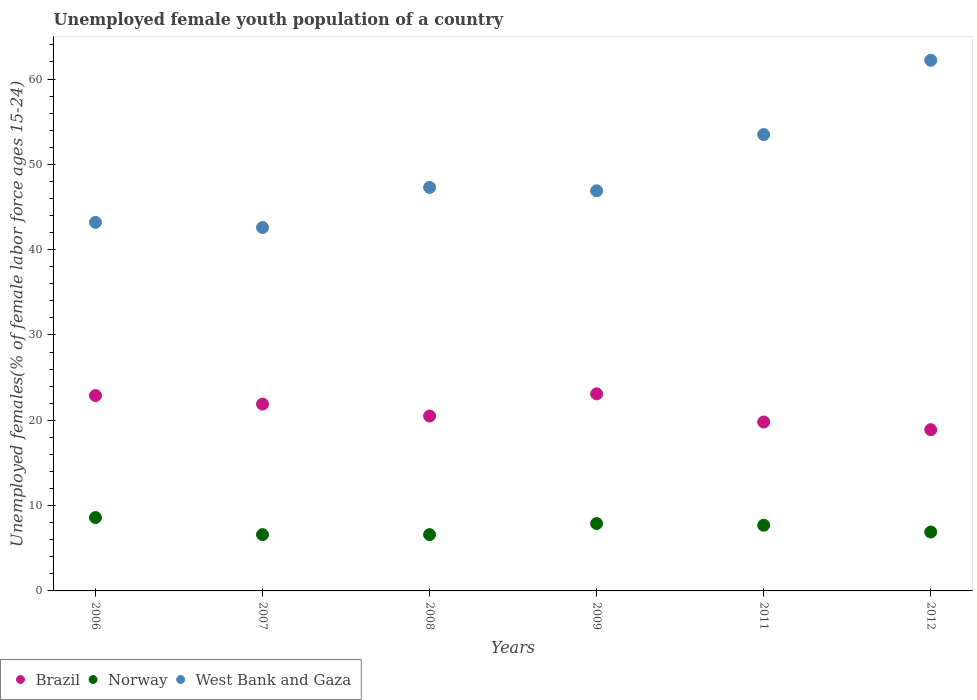Is the number of dotlines equal to the number of legend labels?
Give a very brief answer. Yes. What is the percentage of unemployed female youth population in Norway in 2012?
Ensure brevity in your answer.  6.9. Across all years, what is the maximum percentage of unemployed female youth population in West Bank and Gaza?
Keep it short and to the point. 62.2. Across all years, what is the minimum percentage of unemployed female youth population in West Bank and Gaza?
Keep it short and to the point. 42.6. In which year was the percentage of unemployed female youth population in Norway maximum?
Make the answer very short. 2006. What is the total percentage of unemployed female youth population in Norway in the graph?
Make the answer very short. 44.3. What is the difference between the percentage of unemployed female youth population in Norway in 2007 and that in 2011?
Your answer should be very brief. -1.1. What is the difference between the percentage of unemployed female youth population in Brazil in 2011 and the percentage of unemployed female youth population in West Bank and Gaza in 2007?
Offer a terse response. -22.8. What is the average percentage of unemployed female youth population in West Bank and Gaza per year?
Keep it short and to the point. 49.28. In the year 2012, what is the difference between the percentage of unemployed female youth population in Brazil and percentage of unemployed female youth population in West Bank and Gaza?
Your response must be concise. -43.3. In how many years, is the percentage of unemployed female youth population in Norway greater than 12 %?
Provide a short and direct response. 0. What is the ratio of the percentage of unemployed female youth population in Brazil in 2006 to that in 2011?
Ensure brevity in your answer.  1.16. What is the difference between the highest and the second highest percentage of unemployed female youth population in Norway?
Provide a succinct answer. 0.7. What is the difference between the highest and the lowest percentage of unemployed female youth population in Norway?
Provide a succinct answer. 2. Is the sum of the percentage of unemployed female youth population in Brazil in 2006 and 2008 greater than the maximum percentage of unemployed female youth population in West Bank and Gaza across all years?
Give a very brief answer. No. Is the percentage of unemployed female youth population in Norway strictly greater than the percentage of unemployed female youth population in Brazil over the years?
Offer a very short reply. No. Is the percentage of unemployed female youth population in Brazil strictly less than the percentage of unemployed female youth population in Norway over the years?
Keep it short and to the point. No. How many dotlines are there?
Your response must be concise. 3. How many legend labels are there?
Provide a short and direct response. 3. What is the title of the graph?
Provide a succinct answer. Unemployed female youth population of a country. What is the label or title of the X-axis?
Keep it short and to the point. Years. What is the label or title of the Y-axis?
Give a very brief answer. Unemployed females(% of female labor force ages 15-24). What is the Unemployed females(% of female labor force ages 15-24) in Brazil in 2006?
Offer a terse response. 22.9. What is the Unemployed females(% of female labor force ages 15-24) in Norway in 2006?
Your answer should be very brief. 8.6. What is the Unemployed females(% of female labor force ages 15-24) in West Bank and Gaza in 2006?
Your answer should be compact. 43.2. What is the Unemployed females(% of female labor force ages 15-24) in Brazil in 2007?
Offer a very short reply. 21.9. What is the Unemployed females(% of female labor force ages 15-24) in Norway in 2007?
Make the answer very short. 6.6. What is the Unemployed females(% of female labor force ages 15-24) of West Bank and Gaza in 2007?
Provide a short and direct response. 42.6. What is the Unemployed females(% of female labor force ages 15-24) in Brazil in 2008?
Offer a very short reply. 20.5. What is the Unemployed females(% of female labor force ages 15-24) of Norway in 2008?
Provide a succinct answer. 6.6. What is the Unemployed females(% of female labor force ages 15-24) in West Bank and Gaza in 2008?
Offer a terse response. 47.3. What is the Unemployed females(% of female labor force ages 15-24) of Brazil in 2009?
Make the answer very short. 23.1. What is the Unemployed females(% of female labor force ages 15-24) of Norway in 2009?
Ensure brevity in your answer.  7.9. What is the Unemployed females(% of female labor force ages 15-24) in West Bank and Gaza in 2009?
Give a very brief answer. 46.9. What is the Unemployed females(% of female labor force ages 15-24) of Brazil in 2011?
Give a very brief answer. 19.8. What is the Unemployed females(% of female labor force ages 15-24) of Norway in 2011?
Give a very brief answer. 7.7. What is the Unemployed females(% of female labor force ages 15-24) of West Bank and Gaza in 2011?
Provide a succinct answer. 53.5. What is the Unemployed females(% of female labor force ages 15-24) in Brazil in 2012?
Make the answer very short. 18.9. What is the Unemployed females(% of female labor force ages 15-24) of Norway in 2012?
Your response must be concise. 6.9. What is the Unemployed females(% of female labor force ages 15-24) in West Bank and Gaza in 2012?
Your response must be concise. 62.2. Across all years, what is the maximum Unemployed females(% of female labor force ages 15-24) of Brazil?
Your answer should be very brief. 23.1. Across all years, what is the maximum Unemployed females(% of female labor force ages 15-24) in Norway?
Your answer should be compact. 8.6. Across all years, what is the maximum Unemployed females(% of female labor force ages 15-24) in West Bank and Gaza?
Make the answer very short. 62.2. Across all years, what is the minimum Unemployed females(% of female labor force ages 15-24) in Brazil?
Provide a short and direct response. 18.9. Across all years, what is the minimum Unemployed females(% of female labor force ages 15-24) in Norway?
Your response must be concise. 6.6. Across all years, what is the minimum Unemployed females(% of female labor force ages 15-24) of West Bank and Gaza?
Give a very brief answer. 42.6. What is the total Unemployed females(% of female labor force ages 15-24) in Brazil in the graph?
Offer a very short reply. 127.1. What is the total Unemployed females(% of female labor force ages 15-24) in Norway in the graph?
Keep it short and to the point. 44.3. What is the total Unemployed females(% of female labor force ages 15-24) in West Bank and Gaza in the graph?
Your response must be concise. 295.7. What is the difference between the Unemployed females(% of female labor force ages 15-24) in Norway in 2006 and that in 2007?
Your answer should be very brief. 2. What is the difference between the Unemployed females(% of female labor force ages 15-24) of West Bank and Gaza in 2006 and that in 2007?
Keep it short and to the point. 0.6. What is the difference between the Unemployed females(% of female labor force ages 15-24) in Brazil in 2006 and that in 2008?
Make the answer very short. 2.4. What is the difference between the Unemployed females(% of female labor force ages 15-24) of West Bank and Gaza in 2006 and that in 2008?
Your answer should be compact. -4.1. What is the difference between the Unemployed females(% of female labor force ages 15-24) of Brazil in 2006 and that in 2009?
Offer a very short reply. -0.2. What is the difference between the Unemployed females(% of female labor force ages 15-24) of West Bank and Gaza in 2006 and that in 2009?
Your answer should be very brief. -3.7. What is the difference between the Unemployed females(% of female labor force ages 15-24) of West Bank and Gaza in 2006 and that in 2011?
Your answer should be compact. -10.3. What is the difference between the Unemployed females(% of female labor force ages 15-24) in West Bank and Gaza in 2007 and that in 2008?
Provide a succinct answer. -4.7. What is the difference between the Unemployed females(% of female labor force ages 15-24) in Norway in 2007 and that in 2009?
Your response must be concise. -1.3. What is the difference between the Unemployed females(% of female labor force ages 15-24) of West Bank and Gaza in 2007 and that in 2009?
Provide a short and direct response. -4.3. What is the difference between the Unemployed females(% of female labor force ages 15-24) in Norway in 2007 and that in 2011?
Make the answer very short. -1.1. What is the difference between the Unemployed females(% of female labor force ages 15-24) of Brazil in 2007 and that in 2012?
Your answer should be compact. 3. What is the difference between the Unemployed females(% of female labor force ages 15-24) in West Bank and Gaza in 2007 and that in 2012?
Give a very brief answer. -19.6. What is the difference between the Unemployed females(% of female labor force ages 15-24) of West Bank and Gaza in 2008 and that in 2009?
Your answer should be very brief. 0.4. What is the difference between the Unemployed females(% of female labor force ages 15-24) of Norway in 2008 and that in 2012?
Ensure brevity in your answer.  -0.3. What is the difference between the Unemployed females(% of female labor force ages 15-24) in West Bank and Gaza in 2008 and that in 2012?
Offer a terse response. -14.9. What is the difference between the Unemployed females(% of female labor force ages 15-24) in Brazil in 2009 and that in 2011?
Offer a terse response. 3.3. What is the difference between the Unemployed females(% of female labor force ages 15-24) in West Bank and Gaza in 2009 and that in 2012?
Offer a very short reply. -15.3. What is the difference between the Unemployed females(% of female labor force ages 15-24) in Brazil in 2011 and that in 2012?
Give a very brief answer. 0.9. What is the difference between the Unemployed females(% of female labor force ages 15-24) of Brazil in 2006 and the Unemployed females(% of female labor force ages 15-24) of Norway in 2007?
Your answer should be very brief. 16.3. What is the difference between the Unemployed females(% of female labor force ages 15-24) of Brazil in 2006 and the Unemployed females(% of female labor force ages 15-24) of West Bank and Gaza in 2007?
Provide a short and direct response. -19.7. What is the difference between the Unemployed females(% of female labor force ages 15-24) in Norway in 2006 and the Unemployed females(% of female labor force ages 15-24) in West Bank and Gaza in 2007?
Provide a succinct answer. -34. What is the difference between the Unemployed females(% of female labor force ages 15-24) of Brazil in 2006 and the Unemployed females(% of female labor force ages 15-24) of Norway in 2008?
Offer a terse response. 16.3. What is the difference between the Unemployed females(% of female labor force ages 15-24) in Brazil in 2006 and the Unemployed females(% of female labor force ages 15-24) in West Bank and Gaza in 2008?
Offer a very short reply. -24.4. What is the difference between the Unemployed females(% of female labor force ages 15-24) in Norway in 2006 and the Unemployed females(% of female labor force ages 15-24) in West Bank and Gaza in 2008?
Your answer should be very brief. -38.7. What is the difference between the Unemployed females(% of female labor force ages 15-24) of Norway in 2006 and the Unemployed females(% of female labor force ages 15-24) of West Bank and Gaza in 2009?
Provide a succinct answer. -38.3. What is the difference between the Unemployed females(% of female labor force ages 15-24) of Brazil in 2006 and the Unemployed females(% of female labor force ages 15-24) of West Bank and Gaza in 2011?
Offer a terse response. -30.6. What is the difference between the Unemployed females(% of female labor force ages 15-24) in Norway in 2006 and the Unemployed females(% of female labor force ages 15-24) in West Bank and Gaza in 2011?
Give a very brief answer. -44.9. What is the difference between the Unemployed females(% of female labor force ages 15-24) of Brazil in 2006 and the Unemployed females(% of female labor force ages 15-24) of West Bank and Gaza in 2012?
Offer a terse response. -39.3. What is the difference between the Unemployed females(% of female labor force ages 15-24) of Norway in 2006 and the Unemployed females(% of female labor force ages 15-24) of West Bank and Gaza in 2012?
Provide a succinct answer. -53.6. What is the difference between the Unemployed females(% of female labor force ages 15-24) of Brazil in 2007 and the Unemployed females(% of female labor force ages 15-24) of Norway in 2008?
Your response must be concise. 15.3. What is the difference between the Unemployed females(% of female labor force ages 15-24) of Brazil in 2007 and the Unemployed females(% of female labor force ages 15-24) of West Bank and Gaza in 2008?
Make the answer very short. -25.4. What is the difference between the Unemployed females(% of female labor force ages 15-24) in Norway in 2007 and the Unemployed females(% of female labor force ages 15-24) in West Bank and Gaza in 2008?
Keep it short and to the point. -40.7. What is the difference between the Unemployed females(% of female labor force ages 15-24) in Norway in 2007 and the Unemployed females(% of female labor force ages 15-24) in West Bank and Gaza in 2009?
Keep it short and to the point. -40.3. What is the difference between the Unemployed females(% of female labor force ages 15-24) of Brazil in 2007 and the Unemployed females(% of female labor force ages 15-24) of Norway in 2011?
Offer a very short reply. 14.2. What is the difference between the Unemployed females(% of female labor force ages 15-24) of Brazil in 2007 and the Unemployed females(% of female labor force ages 15-24) of West Bank and Gaza in 2011?
Offer a very short reply. -31.6. What is the difference between the Unemployed females(% of female labor force ages 15-24) of Norway in 2007 and the Unemployed females(% of female labor force ages 15-24) of West Bank and Gaza in 2011?
Offer a very short reply. -46.9. What is the difference between the Unemployed females(% of female labor force ages 15-24) of Brazil in 2007 and the Unemployed females(% of female labor force ages 15-24) of Norway in 2012?
Offer a terse response. 15. What is the difference between the Unemployed females(% of female labor force ages 15-24) in Brazil in 2007 and the Unemployed females(% of female labor force ages 15-24) in West Bank and Gaza in 2012?
Provide a succinct answer. -40.3. What is the difference between the Unemployed females(% of female labor force ages 15-24) of Norway in 2007 and the Unemployed females(% of female labor force ages 15-24) of West Bank and Gaza in 2012?
Ensure brevity in your answer.  -55.6. What is the difference between the Unemployed females(% of female labor force ages 15-24) in Brazil in 2008 and the Unemployed females(% of female labor force ages 15-24) in West Bank and Gaza in 2009?
Ensure brevity in your answer.  -26.4. What is the difference between the Unemployed females(% of female labor force ages 15-24) in Norway in 2008 and the Unemployed females(% of female labor force ages 15-24) in West Bank and Gaza in 2009?
Provide a short and direct response. -40.3. What is the difference between the Unemployed females(% of female labor force ages 15-24) in Brazil in 2008 and the Unemployed females(% of female labor force ages 15-24) in Norway in 2011?
Make the answer very short. 12.8. What is the difference between the Unemployed females(% of female labor force ages 15-24) of Brazil in 2008 and the Unemployed females(% of female labor force ages 15-24) of West Bank and Gaza in 2011?
Ensure brevity in your answer.  -33. What is the difference between the Unemployed females(% of female labor force ages 15-24) of Norway in 2008 and the Unemployed females(% of female labor force ages 15-24) of West Bank and Gaza in 2011?
Provide a succinct answer. -46.9. What is the difference between the Unemployed females(% of female labor force ages 15-24) in Brazil in 2008 and the Unemployed females(% of female labor force ages 15-24) in West Bank and Gaza in 2012?
Your answer should be very brief. -41.7. What is the difference between the Unemployed females(% of female labor force ages 15-24) of Norway in 2008 and the Unemployed females(% of female labor force ages 15-24) of West Bank and Gaza in 2012?
Your answer should be very brief. -55.6. What is the difference between the Unemployed females(% of female labor force ages 15-24) in Brazil in 2009 and the Unemployed females(% of female labor force ages 15-24) in West Bank and Gaza in 2011?
Your answer should be very brief. -30.4. What is the difference between the Unemployed females(% of female labor force ages 15-24) of Norway in 2009 and the Unemployed females(% of female labor force ages 15-24) of West Bank and Gaza in 2011?
Your answer should be very brief. -45.6. What is the difference between the Unemployed females(% of female labor force ages 15-24) of Brazil in 2009 and the Unemployed females(% of female labor force ages 15-24) of Norway in 2012?
Provide a short and direct response. 16.2. What is the difference between the Unemployed females(% of female labor force ages 15-24) in Brazil in 2009 and the Unemployed females(% of female labor force ages 15-24) in West Bank and Gaza in 2012?
Keep it short and to the point. -39.1. What is the difference between the Unemployed females(% of female labor force ages 15-24) of Norway in 2009 and the Unemployed females(% of female labor force ages 15-24) of West Bank and Gaza in 2012?
Provide a succinct answer. -54.3. What is the difference between the Unemployed females(% of female labor force ages 15-24) in Brazil in 2011 and the Unemployed females(% of female labor force ages 15-24) in West Bank and Gaza in 2012?
Give a very brief answer. -42.4. What is the difference between the Unemployed females(% of female labor force ages 15-24) of Norway in 2011 and the Unemployed females(% of female labor force ages 15-24) of West Bank and Gaza in 2012?
Offer a very short reply. -54.5. What is the average Unemployed females(% of female labor force ages 15-24) of Brazil per year?
Keep it short and to the point. 21.18. What is the average Unemployed females(% of female labor force ages 15-24) in Norway per year?
Your answer should be very brief. 7.38. What is the average Unemployed females(% of female labor force ages 15-24) of West Bank and Gaza per year?
Your answer should be compact. 49.28. In the year 2006, what is the difference between the Unemployed females(% of female labor force ages 15-24) of Brazil and Unemployed females(% of female labor force ages 15-24) of West Bank and Gaza?
Give a very brief answer. -20.3. In the year 2006, what is the difference between the Unemployed females(% of female labor force ages 15-24) of Norway and Unemployed females(% of female labor force ages 15-24) of West Bank and Gaza?
Keep it short and to the point. -34.6. In the year 2007, what is the difference between the Unemployed females(% of female labor force ages 15-24) in Brazil and Unemployed females(% of female labor force ages 15-24) in Norway?
Make the answer very short. 15.3. In the year 2007, what is the difference between the Unemployed females(% of female labor force ages 15-24) of Brazil and Unemployed females(% of female labor force ages 15-24) of West Bank and Gaza?
Provide a succinct answer. -20.7. In the year 2007, what is the difference between the Unemployed females(% of female labor force ages 15-24) in Norway and Unemployed females(% of female labor force ages 15-24) in West Bank and Gaza?
Your answer should be compact. -36. In the year 2008, what is the difference between the Unemployed females(% of female labor force ages 15-24) of Brazil and Unemployed females(% of female labor force ages 15-24) of West Bank and Gaza?
Your answer should be compact. -26.8. In the year 2008, what is the difference between the Unemployed females(% of female labor force ages 15-24) of Norway and Unemployed females(% of female labor force ages 15-24) of West Bank and Gaza?
Offer a terse response. -40.7. In the year 2009, what is the difference between the Unemployed females(% of female labor force ages 15-24) in Brazil and Unemployed females(% of female labor force ages 15-24) in West Bank and Gaza?
Offer a very short reply. -23.8. In the year 2009, what is the difference between the Unemployed females(% of female labor force ages 15-24) in Norway and Unemployed females(% of female labor force ages 15-24) in West Bank and Gaza?
Your response must be concise. -39. In the year 2011, what is the difference between the Unemployed females(% of female labor force ages 15-24) in Brazil and Unemployed females(% of female labor force ages 15-24) in West Bank and Gaza?
Ensure brevity in your answer.  -33.7. In the year 2011, what is the difference between the Unemployed females(% of female labor force ages 15-24) in Norway and Unemployed females(% of female labor force ages 15-24) in West Bank and Gaza?
Provide a short and direct response. -45.8. In the year 2012, what is the difference between the Unemployed females(% of female labor force ages 15-24) in Brazil and Unemployed females(% of female labor force ages 15-24) in Norway?
Provide a succinct answer. 12. In the year 2012, what is the difference between the Unemployed females(% of female labor force ages 15-24) of Brazil and Unemployed females(% of female labor force ages 15-24) of West Bank and Gaza?
Your answer should be very brief. -43.3. In the year 2012, what is the difference between the Unemployed females(% of female labor force ages 15-24) of Norway and Unemployed females(% of female labor force ages 15-24) of West Bank and Gaza?
Keep it short and to the point. -55.3. What is the ratio of the Unemployed females(% of female labor force ages 15-24) of Brazil in 2006 to that in 2007?
Your answer should be very brief. 1.05. What is the ratio of the Unemployed females(% of female labor force ages 15-24) in Norway in 2006 to that in 2007?
Provide a succinct answer. 1.3. What is the ratio of the Unemployed females(% of female labor force ages 15-24) in West Bank and Gaza in 2006 to that in 2007?
Keep it short and to the point. 1.01. What is the ratio of the Unemployed females(% of female labor force ages 15-24) of Brazil in 2006 to that in 2008?
Give a very brief answer. 1.12. What is the ratio of the Unemployed females(% of female labor force ages 15-24) of Norway in 2006 to that in 2008?
Your answer should be very brief. 1.3. What is the ratio of the Unemployed females(% of female labor force ages 15-24) of West Bank and Gaza in 2006 to that in 2008?
Offer a terse response. 0.91. What is the ratio of the Unemployed females(% of female labor force ages 15-24) of Brazil in 2006 to that in 2009?
Ensure brevity in your answer.  0.99. What is the ratio of the Unemployed females(% of female labor force ages 15-24) in Norway in 2006 to that in 2009?
Provide a succinct answer. 1.09. What is the ratio of the Unemployed females(% of female labor force ages 15-24) in West Bank and Gaza in 2006 to that in 2009?
Your answer should be very brief. 0.92. What is the ratio of the Unemployed females(% of female labor force ages 15-24) of Brazil in 2006 to that in 2011?
Offer a terse response. 1.16. What is the ratio of the Unemployed females(% of female labor force ages 15-24) of Norway in 2006 to that in 2011?
Make the answer very short. 1.12. What is the ratio of the Unemployed females(% of female labor force ages 15-24) of West Bank and Gaza in 2006 to that in 2011?
Offer a very short reply. 0.81. What is the ratio of the Unemployed females(% of female labor force ages 15-24) of Brazil in 2006 to that in 2012?
Provide a succinct answer. 1.21. What is the ratio of the Unemployed females(% of female labor force ages 15-24) in Norway in 2006 to that in 2012?
Ensure brevity in your answer.  1.25. What is the ratio of the Unemployed females(% of female labor force ages 15-24) in West Bank and Gaza in 2006 to that in 2012?
Provide a succinct answer. 0.69. What is the ratio of the Unemployed females(% of female labor force ages 15-24) in Brazil in 2007 to that in 2008?
Make the answer very short. 1.07. What is the ratio of the Unemployed females(% of female labor force ages 15-24) of Norway in 2007 to that in 2008?
Offer a very short reply. 1. What is the ratio of the Unemployed females(% of female labor force ages 15-24) in West Bank and Gaza in 2007 to that in 2008?
Make the answer very short. 0.9. What is the ratio of the Unemployed females(% of female labor force ages 15-24) in Brazil in 2007 to that in 2009?
Your response must be concise. 0.95. What is the ratio of the Unemployed females(% of female labor force ages 15-24) of Norway in 2007 to that in 2009?
Make the answer very short. 0.84. What is the ratio of the Unemployed females(% of female labor force ages 15-24) of West Bank and Gaza in 2007 to that in 2009?
Give a very brief answer. 0.91. What is the ratio of the Unemployed females(% of female labor force ages 15-24) of Brazil in 2007 to that in 2011?
Give a very brief answer. 1.11. What is the ratio of the Unemployed females(% of female labor force ages 15-24) of West Bank and Gaza in 2007 to that in 2011?
Your answer should be compact. 0.8. What is the ratio of the Unemployed females(% of female labor force ages 15-24) of Brazil in 2007 to that in 2012?
Your answer should be compact. 1.16. What is the ratio of the Unemployed females(% of female labor force ages 15-24) of Norway in 2007 to that in 2012?
Your answer should be very brief. 0.96. What is the ratio of the Unemployed females(% of female labor force ages 15-24) in West Bank and Gaza in 2007 to that in 2012?
Give a very brief answer. 0.68. What is the ratio of the Unemployed females(% of female labor force ages 15-24) of Brazil in 2008 to that in 2009?
Your response must be concise. 0.89. What is the ratio of the Unemployed females(% of female labor force ages 15-24) of Norway in 2008 to that in 2009?
Your answer should be compact. 0.84. What is the ratio of the Unemployed females(% of female labor force ages 15-24) of West Bank and Gaza in 2008 to that in 2009?
Make the answer very short. 1.01. What is the ratio of the Unemployed females(% of female labor force ages 15-24) of Brazil in 2008 to that in 2011?
Keep it short and to the point. 1.04. What is the ratio of the Unemployed females(% of female labor force ages 15-24) in West Bank and Gaza in 2008 to that in 2011?
Provide a short and direct response. 0.88. What is the ratio of the Unemployed females(% of female labor force ages 15-24) of Brazil in 2008 to that in 2012?
Ensure brevity in your answer.  1.08. What is the ratio of the Unemployed females(% of female labor force ages 15-24) in Norway in 2008 to that in 2012?
Your answer should be compact. 0.96. What is the ratio of the Unemployed females(% of female labor force ages 15-24) in West Bank and Gaza in 2008 to that in 2012?
Your answer should be compact. 0.76. What is the ratio of the Unemployed females(% of female labor force ages 15-24) in Brazil in 2009 to that in 2011?
Keep it short and to the point. 1.17. What is the ratio of the Unemployed females(% of female labor force ages 15-24) in Norway in 2009 to that in 2011?
Your response must be concise. 1.03. What is the ratio of the Unemployed females(% of female labor force ages 15-24) of West Bank and Gaza in 2009 to that in 2011?
Your answer should be very brief. 0.88. What is the ratio of the Unemployed females(% of female labor force ages 15-24) in Brazil in 2009 to that in 2012?
Your answer should be very brief. 1.22. What is the ratio of the Unemployed females(% of female labor force ages 15-24) of Norway in 2009 to that in 2012?
Keep it short and to the point. 1.14. What is the ratio of the Unemployed females(% of female labor force ages 15-24) in West Bank and Gaza in 2009 to that in 2012?
Give a very brief answer. 0.75. What is the ratio of the Unemployed females(% of female labor force ages 15-24) of Brazil in 2011 to that in 2012?
Provide a short and direct response. 1.05. What is the ratio of the Unemployed females(% of female labor force ages 15-24) in Norway in 2011 to that in 2012?
Provide a succinct answer. 1.12. What is the ratio of the Unemployed females(% of female labor force ages 15-24) of West Bank and Gaza in 2011 to that in 2012?
Ensure brevity in your answer.  0.86. What is the difference between the highest and the second highest Unemployed females(% of female labor force ages 15-24) of Norway?
Make the answer very short. 0.7. What is the difference between the highest and the second highest Unemployed females(% of female labor force ages 15-24) of West Bank and Gaza?
Your answer should be compact. 8.7. What is the difference between the highest and the lowest Unemployed females(% of female labor force ages 15-24) of Brazil?
Your answer should be compact. 4.2. What is the difference between the highest and the lowest Unemployed females(% of female labor force ages 15-24) of Norway?
Keep it short and to the point. 2. What is the difference between the highest and the lowest Unemployed females(% of female labor force ages 15-24) of West Bank and Gaza?
Offer a very short reply. 19.6. 